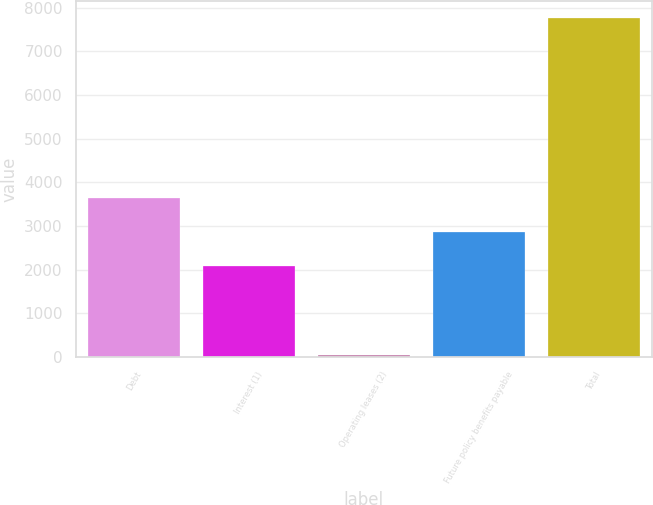<chart> <loc_0><loc_0><loc_500><loc_500><bar_chart><fcel>Debt<fcel>Interest (1)<fcel>Operating leases (2)<fcel>Future policy benefits payable<fcel>Total<nl><fcel>3637<fcel>2095<fcel>52<fcel>2866<fcel>7762<nl></chart> 